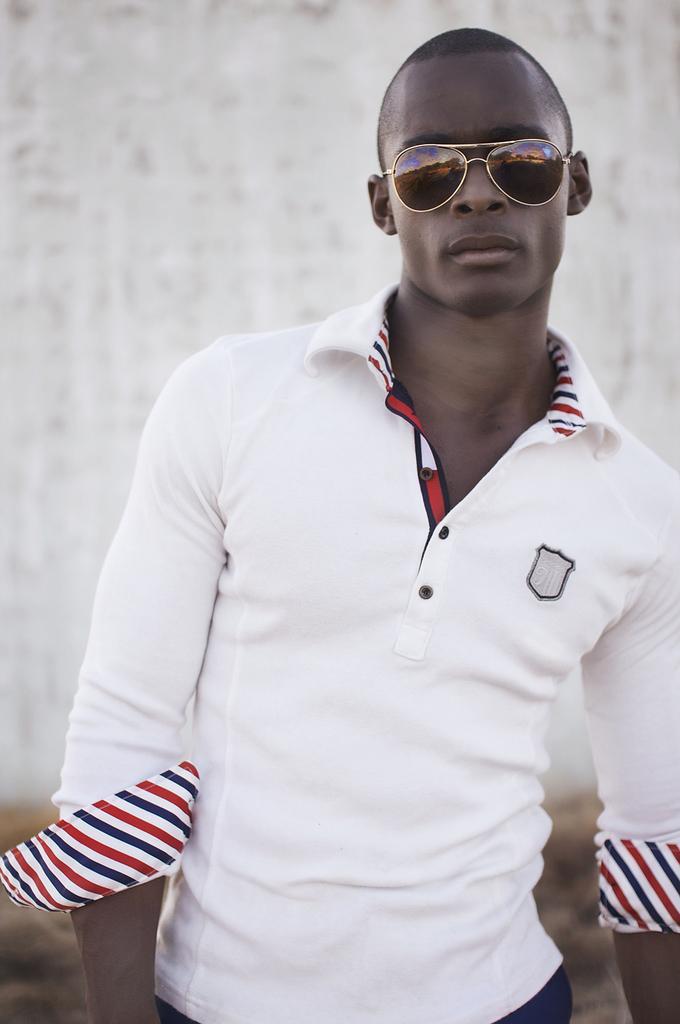Could you give a brief overview of what you see in this image? This is the man standing. He wore goggles and white T-shirt. In the background, that looks like a wall, which is white in color. 